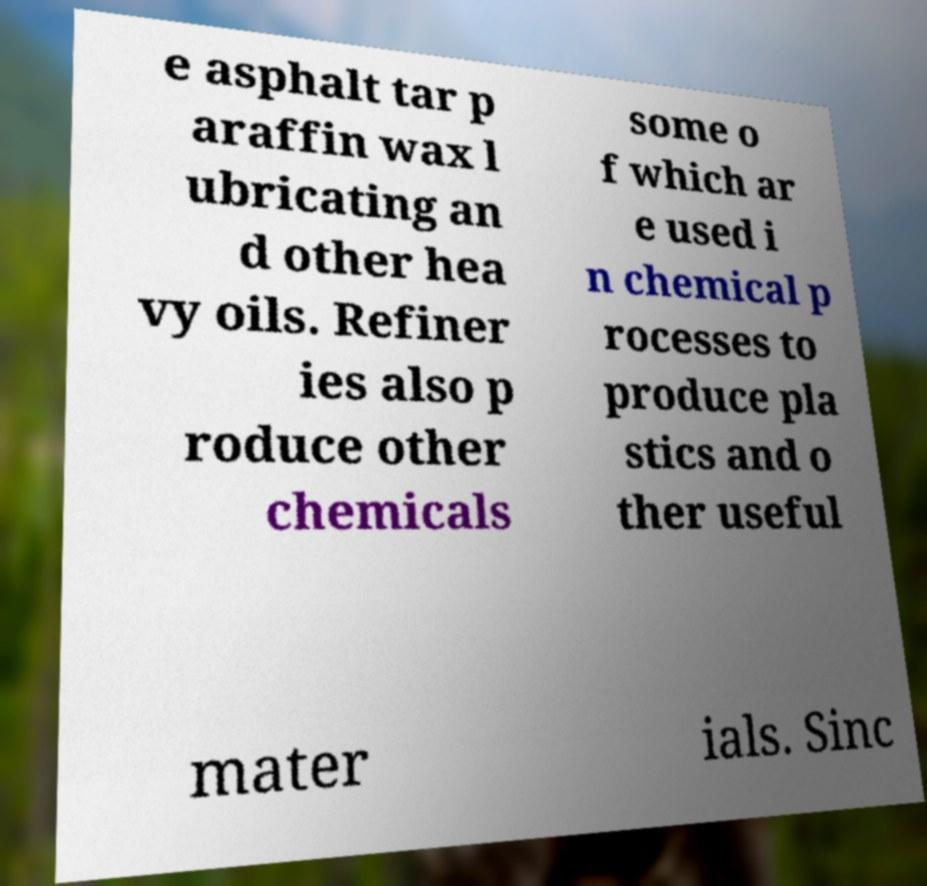Can you read and provide the text displayed in the image?This photo seems to have some interesting text. Can you extract and type it out for me? e asphalt tar p araffin wax l ubricating an d other hea vy oils. Refiner ies also p roduce other chemicals some o f which ar e used i n chemical p rocesses to produce pla stics and o ther useful mater ials. Sinc 